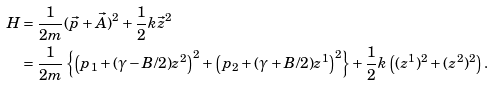Convert formula to latex. <formula><loc_0><loc_0><loc_500><loc_500>H & = \frac { 1 } { 2 m } ( \vec { p } + \vec { A } ) ^ { 2 } + \frac { 1 } { 2 } k \vec { z } ^ { 2 } \\ & = \frac { 1 } { 2 m } \left \{ \left ( p _ { 1 } + ( \gamma - B / 2 ) z ^ { 2 } \right ) ^ { 2 } + \left ( p _ { 2 } + ( \gamma + B / 2 ) z ^ { 1 } \right ) ^ { 2 } \right \} + \frac { 1 } { 2 } k \left ( ( z ^ { 1 } ) ^ { 2 } + ( z ^ { 2 } ) ^ { 2 } \right ) .</formula> 